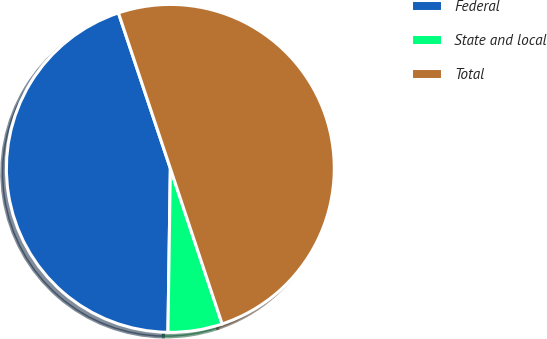<chart> <loc_0><loc_0><loc_500><loc_500><pie_chart><fcel>Federal<fcel>State and local<fcel>Total<nl><fcel>44.64%<fcel>5.35%<fcel>50.02%<nl></chart> 